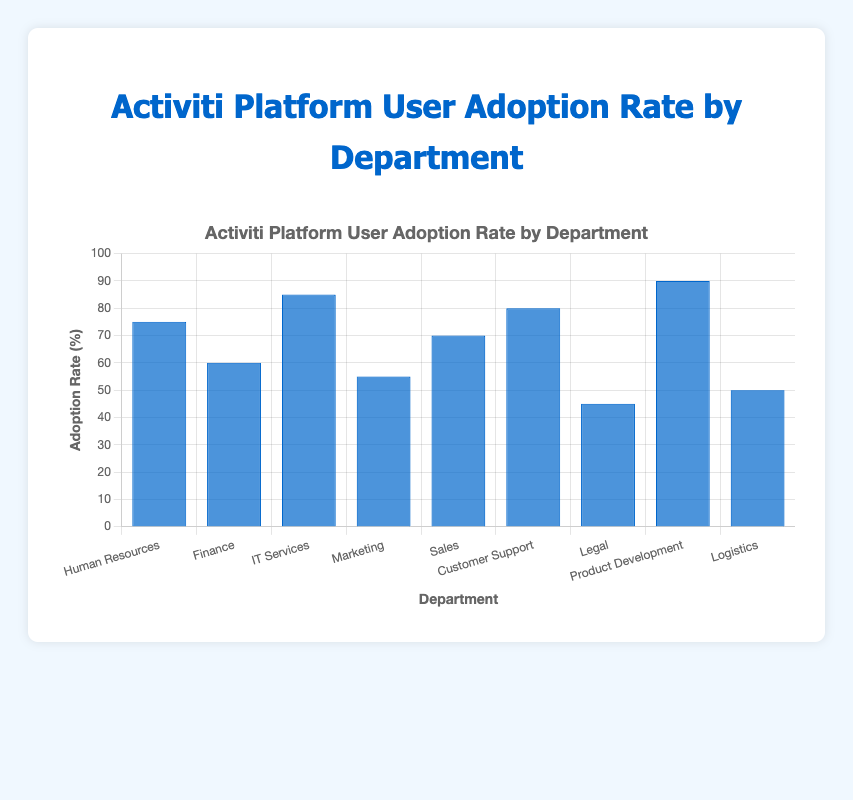What is the user adoption rate of the Legal department? Look at the bar corresponding to the Legal department. The height of the bar indicates the adoption rate, which is 45%.
Answer: 45% Which department has the highest user adoption rate? Identify the tallest bar, which represents the highest user adoption rate. The tallest bar belongs to the Product Development department, indicating a 90% adoption rate.
Answer: Product Development What is the difference in user adoption rate between IT Services and Marketing? Find the adoption rates for IT Services and Marketing. IT Services is 85%, and Marketing is 55%. The difference is 85% - 55% = 30%.
Answer: 30% Which department has a lower user adoption rate, Sales or Logistics? Compare the heights of the bars for Sales and Logistics. Sales has an adoption rate of 70%, while Logistics has an adoption rate of 50%. Logistics is lower.
Answer: Logistics How many departments have a user adoption rate of at least 70%? Count the departments with bars reaching or exceeding 70%. These are Human Resources (75%), IT Services (85%), Sales (70%), Customer Support (80%), and Product Development (90%), making 5 departments in total.
Answer: 5 What is the average user adoption rate of Human Resources, Finance, and Marketing? Sum the adoption rates for these departments (Human Resources: 75%, Finance: 60%, Marketing: 55%) and divide by 3. The average is (75 + 60 + 55) / 3 = 63.33%.
Answer: 63.33% Which department has an adoption rate closest to the median rate of all departments? List all adoption rates: 45%, 50%, 55%, 60%, 70%, 75%, 80%, 85%, 90%. The median value for an odd number of observations (n=9) is the middle value, which is 70%. Sales has an adoption rate closest to this median value.
Answer: Sales Is the user adoption rate of Customer Support greater than the average adoption rate of Marketing and Logistics? Calculate the average adoption rate of Marketing (55%) and Logistics (50%). The average is (55 + 50) / 2 = 52.5%. Compare this with Customer Support's rate (80%). Since 80% > 52.5%, the answer is yes.
Answer: Yes 